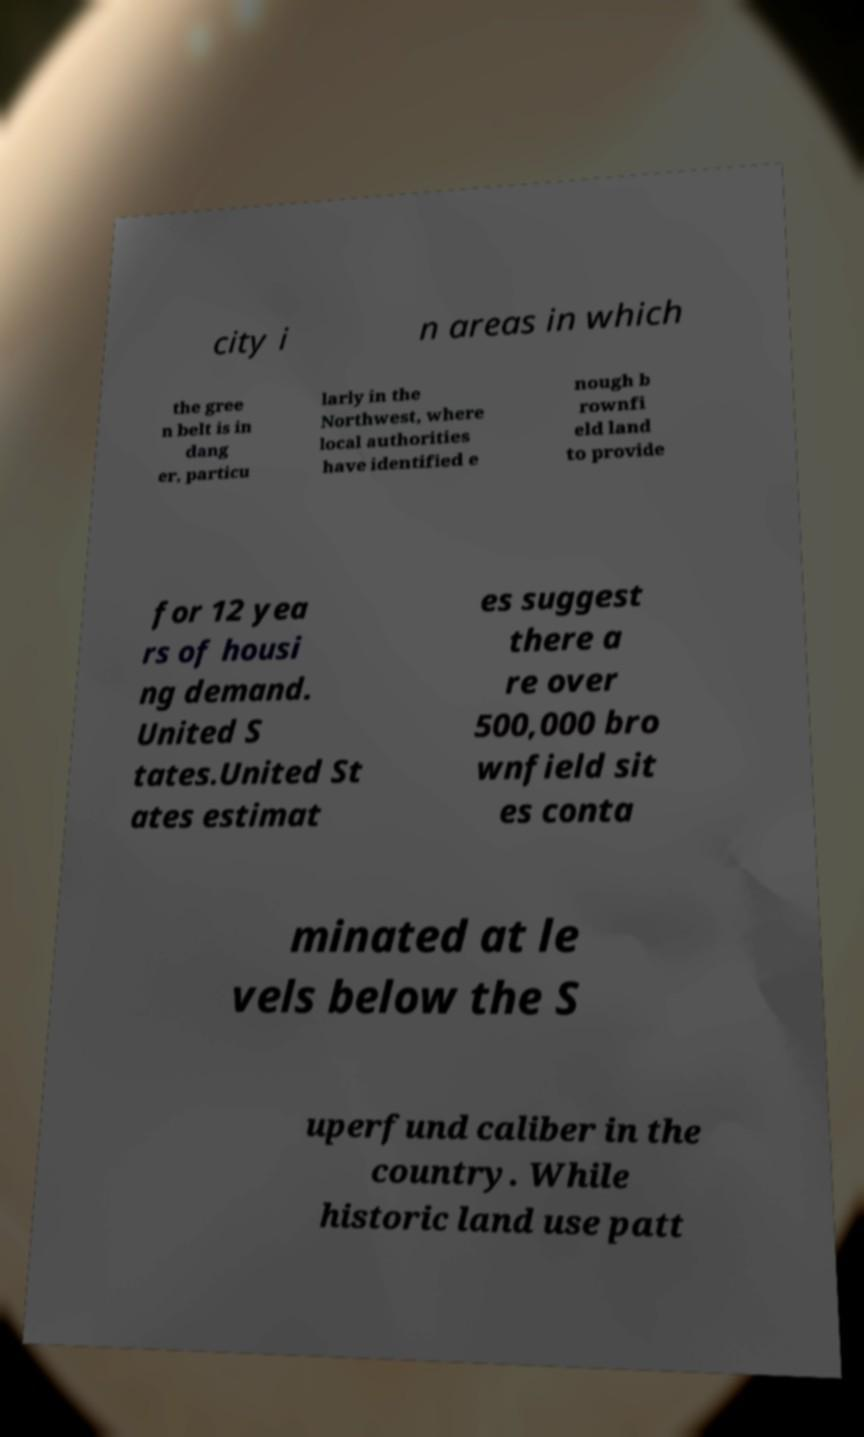Could you assist in decoding the text presented in this image and type it out clearly? city i n areas in which the gree n belt is in dang er, particu larly in the Northwest, where local authorities have identified e nough b rownfi eld land to provide for 12 yea rs of housi ng demand. United S tates.United St ates estimat es suggest there a re over 500,000 bro wnfield sit es conta minated at le vels below the S uperfund caliber in the country. While historic land use patt 